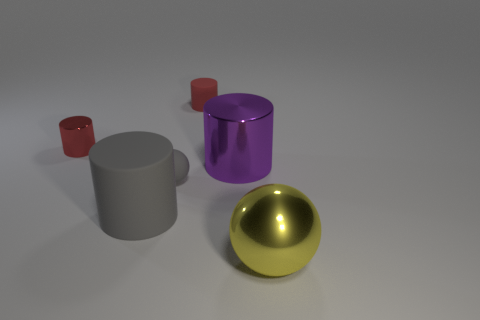There is another cylinder that is the same color as the tiny metallic cylinder; what is it made of?
Offer a very short reply. Rubber. What number of small objects are the same material as the purple cylinder?
Offer a very short reply. 1. The other small thing that is made of the same material as the tiny gray thing is what color?
Your answer should be very brief. Red. There is a matte cylinder that is behind the metal object that is left of the tiny cylinder that is behind the small red shiny thing; what is its size?
Ensure brevity in your answer.  Small. Is the number of red matte cylinders less than the number of purple metal blocks?
Your response must be concise. No. The other matte object that is the same shape as the big rubber thing is what color?
Keep it short and to the point. Red. Is there a gray rubber thing left of the small thing in front of the tiny red thing that is to the left of the red rubber object?
Offer a very short reply. Yes. Does the big yellow object have the same shape as the purple object?
Provide a succinct answer. No. Is the number of yellow metallic balls that are to the left of the large gray matte cylinder less than the number of small cylinders?
Ensure brevity in your answer.  Yes. What is the color of the matte cylinder that is behind the red object that is in front of the tiny red cylinder on the right side of the big rubber cylinder?
Offer a very short reply. Red. 